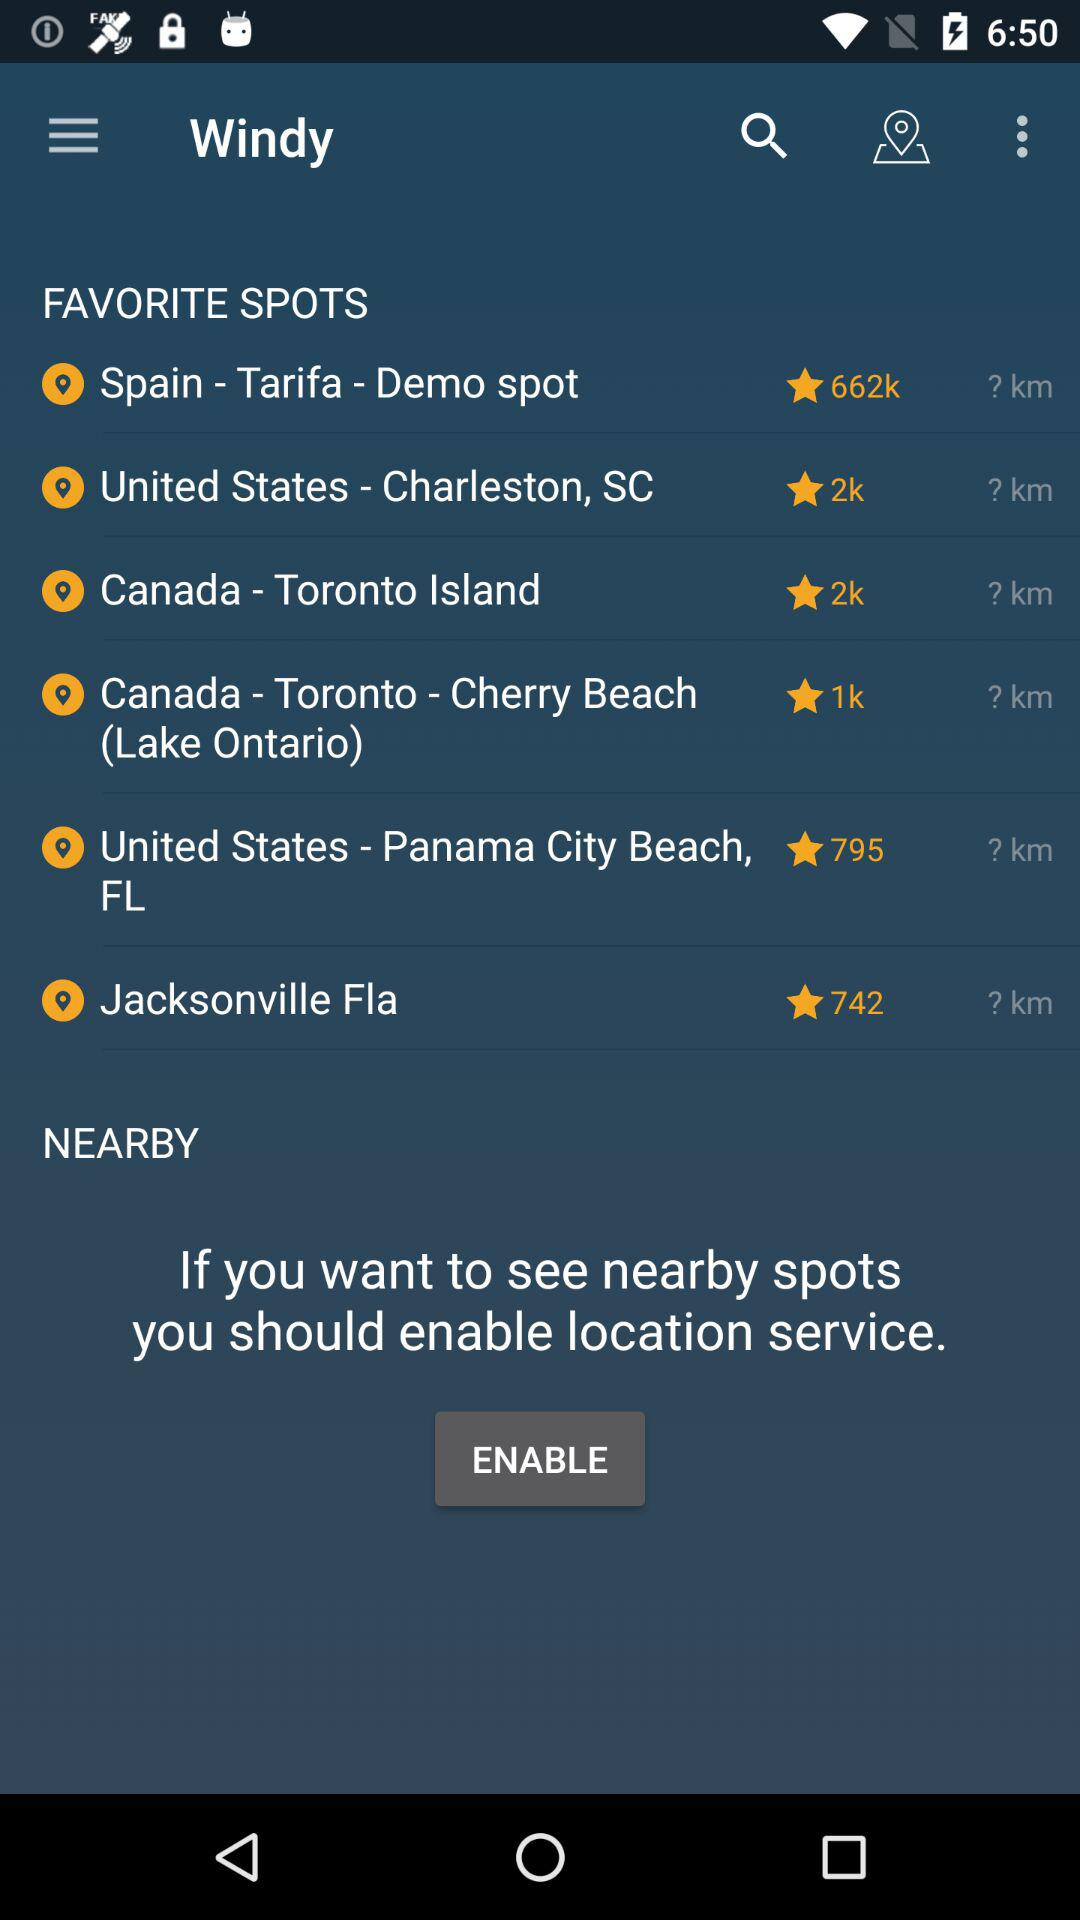What are the available favorite spots? The available favorite spots are Demo spot, Tarifa, Spain; Charleston, South Carolina, the United States; Toronto Island, Canada; Cherry Beach (Lake Ontario), Toronto, Canada; Panama City Beach, Florida, the United States and Jacksonville Fla. 